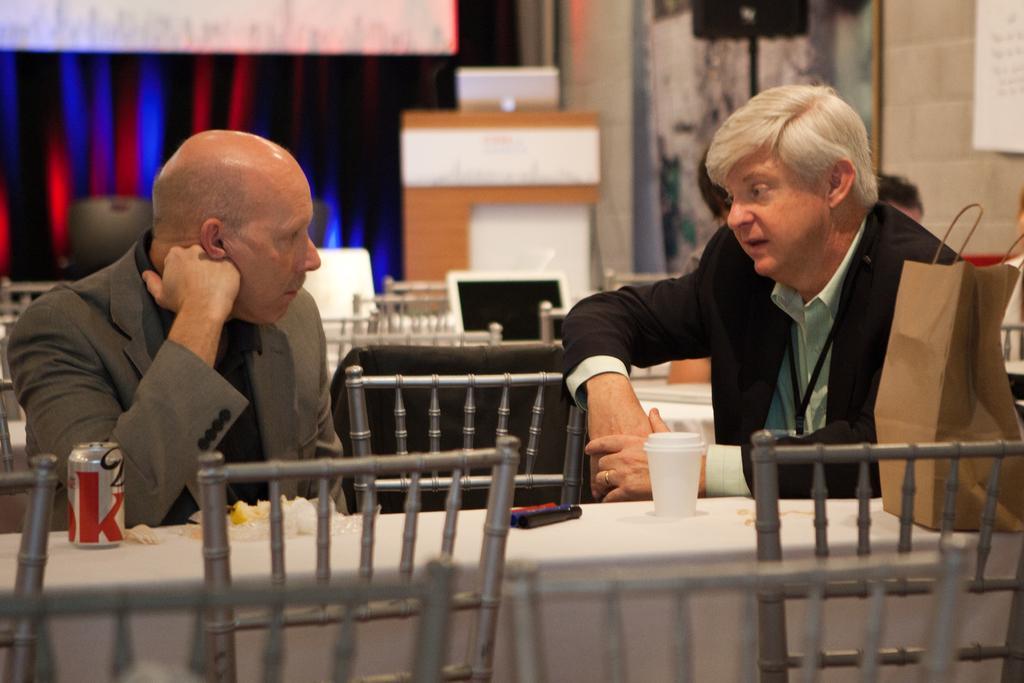Please provide a concise description of this image. In the picture I can see two people wearing coats are sitting on the chairs near the table where cups, tin, paper bag and a few more objects are placed on the table. The background of the image is slightly blurred, where we can see few more chairs, I can see the monitor, a podium upon which laptop is placed, I can see the curtains and few more objects. 